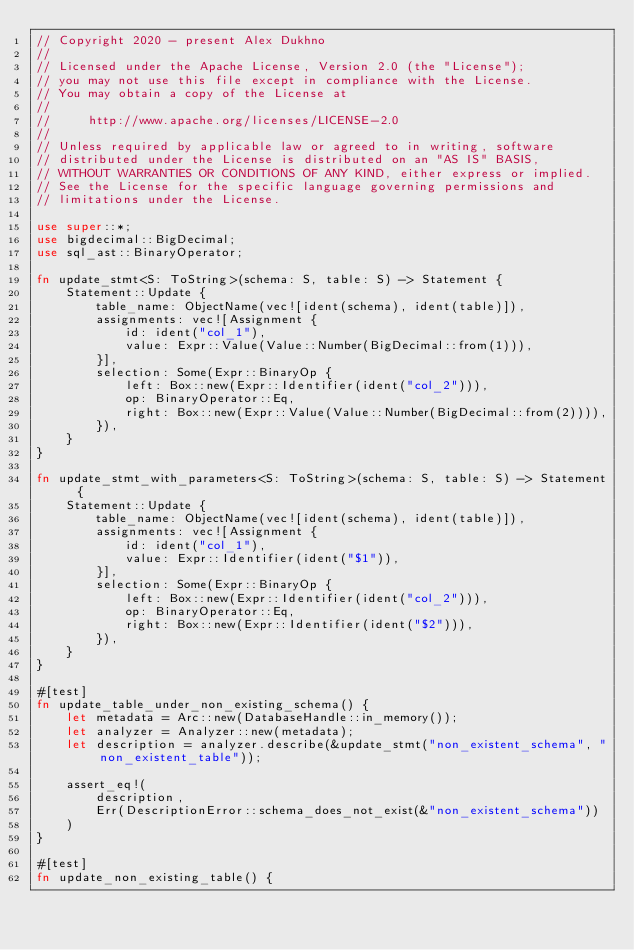Convert code to text. <code><loc_0><loc_0><loc_500><loc_500><_Rust_>// Copyright 2020 - present Alex Dukhno
//
// Licensed under the Apache License, Version 2.0 (the "License");
// you may not use this file except in compliance with the License.
// You may obtain a copy of the License at
//
//     http://www.apache.org/licenses/LICENSE-2.0
//
// Unless required by applicable law or agreed to in writing, software
// distributed under the License is distributed on an "AS IS" BASIS,
// WITHOUT WARRANTIES OR CONDITIONS OF ANY KIND, either express or implied.
// See the License for the specific language governing permissions and
// limitations under the License.

use super::*;
use bigdecimal::BigDecimal;
use sql_ast::BinaryOperator;

fn update_stmt<S: ToString>(schema: S, table: S) -> Statement {
    Statement::Update {
        table_name: ObjectName(vec![ident(schema), ident(table)]),
        assignments: vec![Assignment {
            id: ident("col_1"),
            value: Expr::Value(Value::Number(BigDecimal::from(1))),
        }],
        selection: Some(Expr::BinaryOp {
            left: Box::new(Expr::Identifier(ident("col_2"))),
            op: BinaryOperator::Eq,
            right: Box::new(Expr::Value(Value::Number(BigDecimal::from(2)))),
        }),
    }
}

fn update_stmt_with_parameters<S: ToString>(schema: S, table: S) -> Statement {
    Statement::Update {
        table_name: ObjectName(vec![ident(schema), ident(table)]),
        assignments: vec![Assignment {
            id: ident("col_1"),
            value: Expr::Identifier(ident("$1")),
        }],
        selection: Some(Expr::BinaryOp {
            left: Box::new(Expr::Identifier(ident("col_2"))),
            op: BinaryOperator::Eq,
            right: Box::new(Expr::Identifier(ident("$2"))),
        }),
    }
}

#[test]
fn update_table_under_non_existing_schema() {
    let metadata = Arc::new(DatabaseHandle::in_memory());
    let analyzer = Analyzer::new(metadata);
    let description = analyzer.describe(&update_stmt("non_existent_schema", "non_existent_table"));

    assert_eq!(
        description,
        Err(DescriptionError::schema_does_not_exist(&"non_existent_schema"))
    )
}

#[test]
fn update_non_existing_table() {</code> 